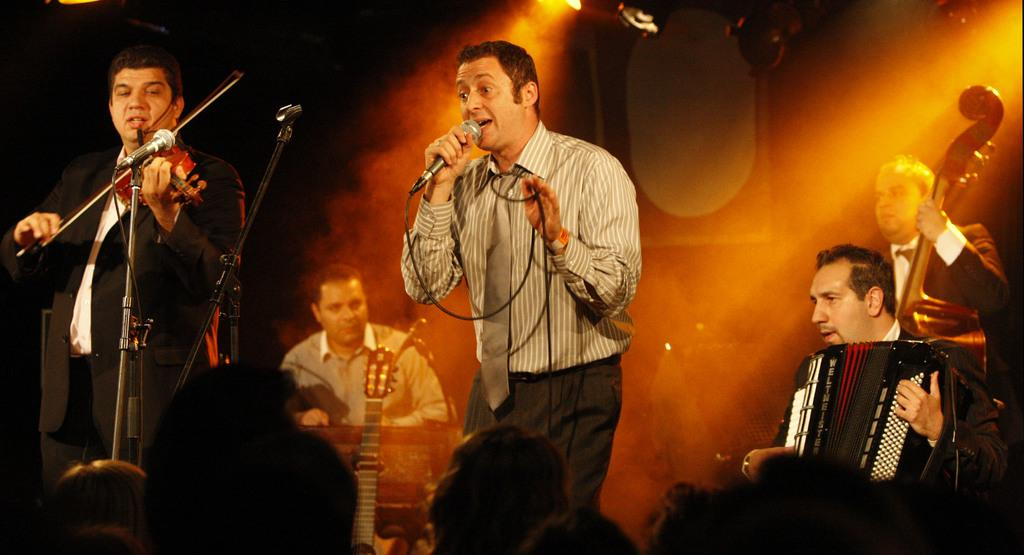What is the person in the image wearing on their lower body? The person is wearing black pants in the image. What is the person doing with the microphone? The person is singing in front of a microphone. Who else is present in the image besides the singer? There is a group of people playing music behind the singer. Who is the target audience for the performance in the image? There is an audience in front of the musicians. How many apples are being used as percussion instruments in the image? There are no apples present in the image; the musicians are playing traditional instruments. 